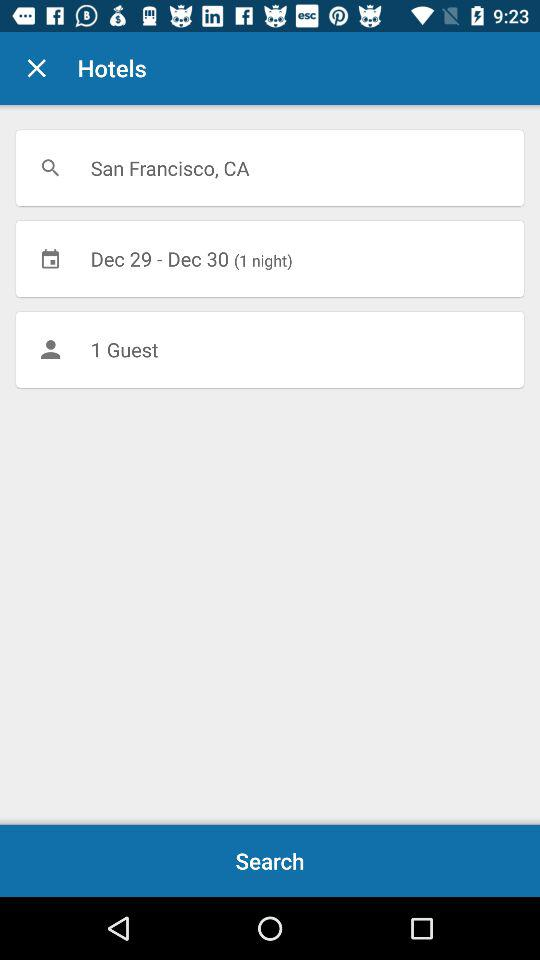How many people are the user searching for?
Answer the question using a single word or phrase. 1 